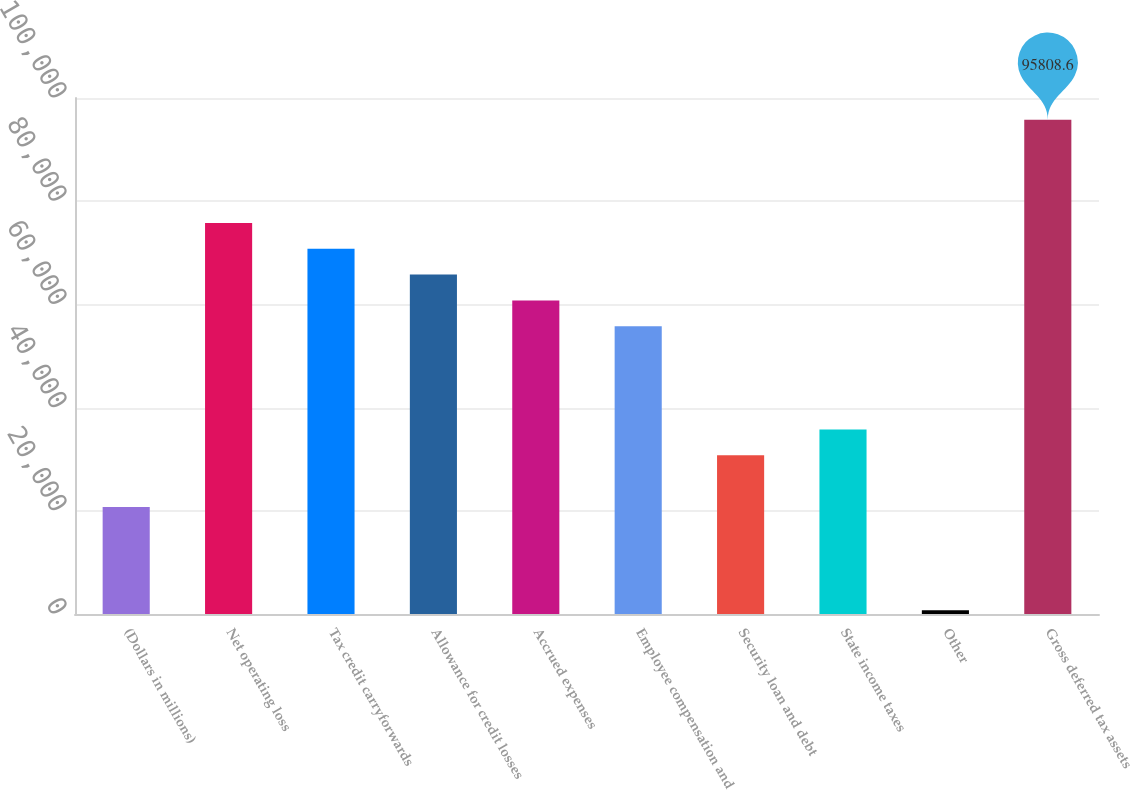Convert chart to OTSL. <chart><loc_0><loc_0><loc_500><loc_500><bar_chart><fcel>(Dollars in millions)<fcel>Net operating loss<fcel>Tax credit carryforwards<fcel>Allowance for credit losses<fcel>Accrued expenses<fcel>Employee compensation and<fcel>Security loan and debt<fcel>State income taxes<fcel>Other<fcel>Gross deferred tax assets<nl><fcel>20742.6<fcel>75791<fcel>70786.6<fcel>65782.2<fcel>60777.8<fcel>55773.4<fcel>30751.4<fcel>35755.8<fcel>725<fcel>95808.6<nl></chart> 